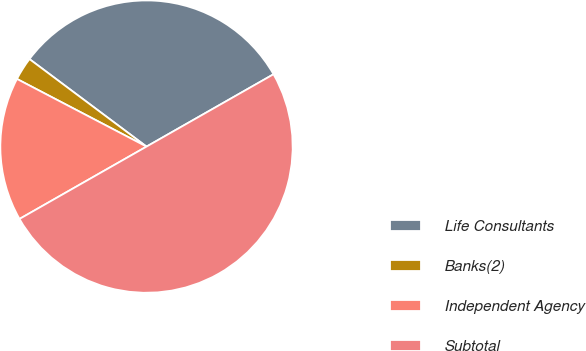Convert chart to OTSL. <chart><loc_0><loc_0><loc_500><loc_500><pie_chart><fcel>Life Consultants<fcel>Banks(2)<fcel>Independent Agency<fcel>Subtotal<nl><fcel>31.54%<fcel>2.56%<fcel>15.9%<fcel>50.0%<nl></chart> 